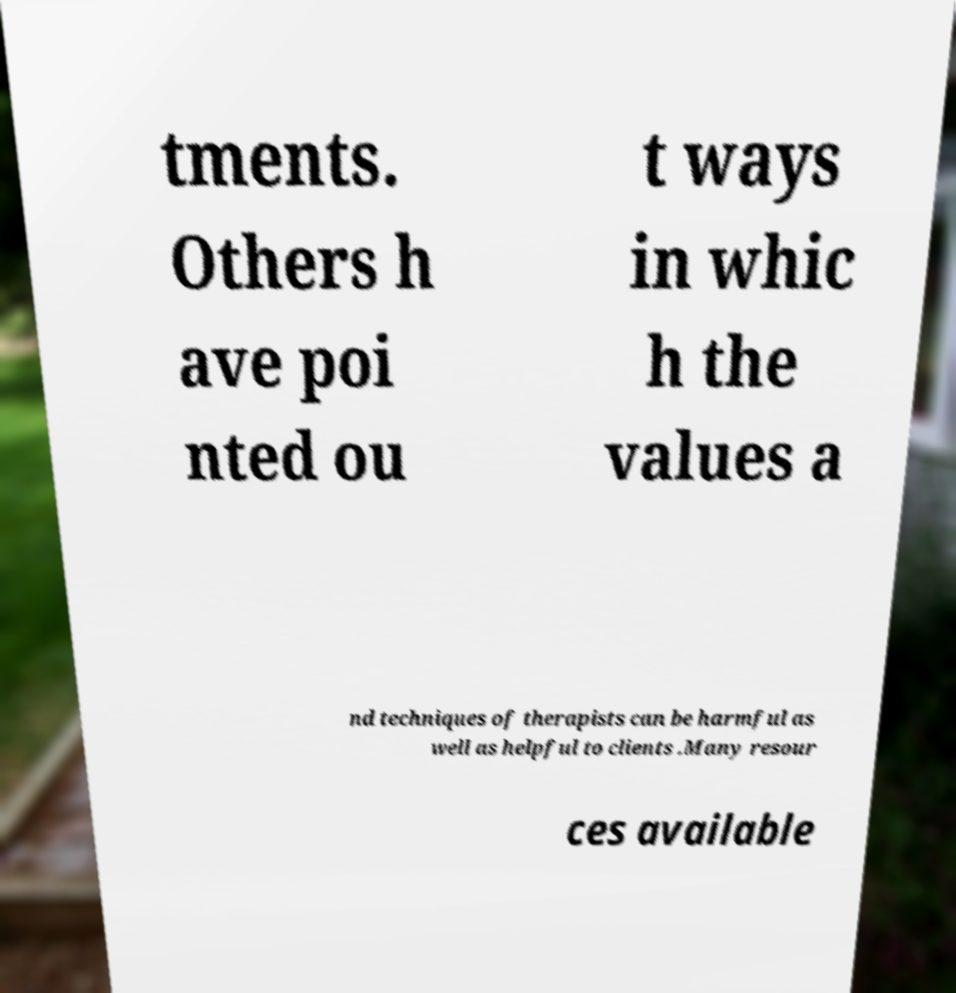What messages or text are displayed in this image? I need them in a readable, typed format. tments. Others h ave poi nted ou t ways in whic h the values a nd techniques of therapists can be harmful as well as helpful to clients .Many resour ces available 